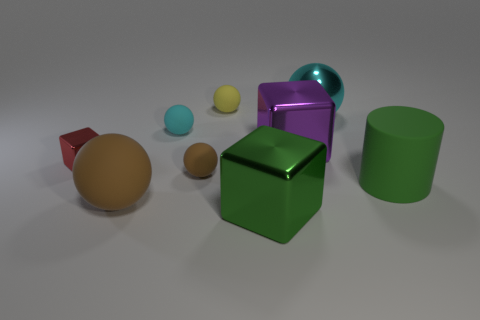Subtract all large metallic spheres. How many spheres are left? 4 Subtract all green blocks. How many blocks are left? 2 Subtract all cubes. How many objects are left? 6 Subtract all blue blocks. How many yellow spheres are left? 1 Add 7 small cyan balls. How many small cyan balls exist? 8 Add 1 brown rubber cylinders. How many objects exist? 10 Subtract 1 red cubes. How many objects are left? 8 Subtract 4 balls. How many balls are left? 1 Subtract all gray blocks. Subtract all blue spheres. How many blocks are left? 3 Subtract all green blocks. Subtract all small gray spheres. How many objects are left? 8 